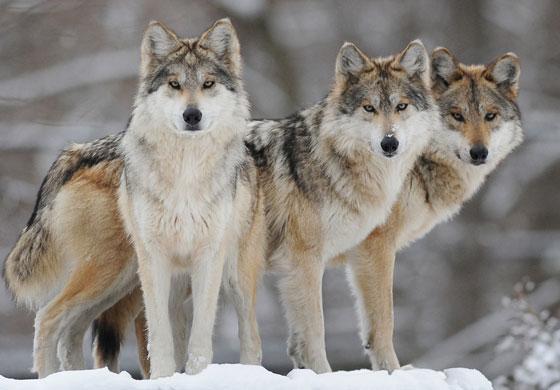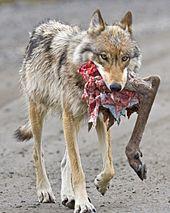The first image is the image on the left, the second image is the image on the right. Considering the images on both sides, is "The right image contains at least two wolves." valid? Answer yes or no. No. 